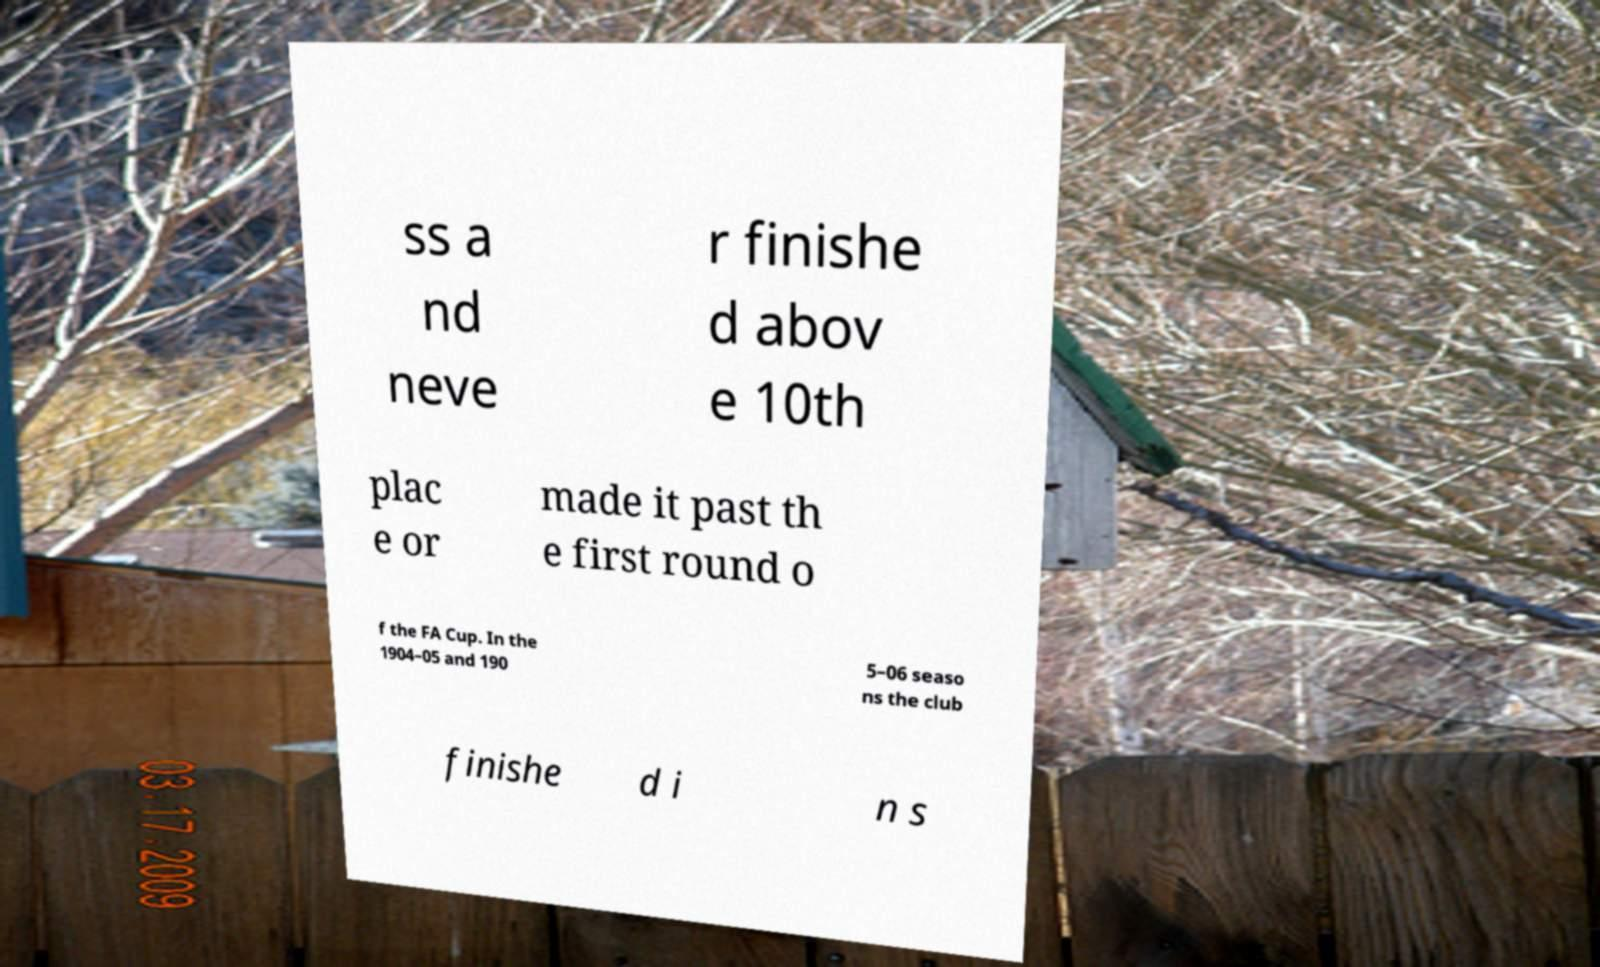Please read and relay the text visible in this image. What does it say? ss a nd neve r finishe d abov e 10th plac e or made it past th e first round o f the FA Cup. In the 1904–05 and 190 5–06 seaso ns the club finishe d i n s 